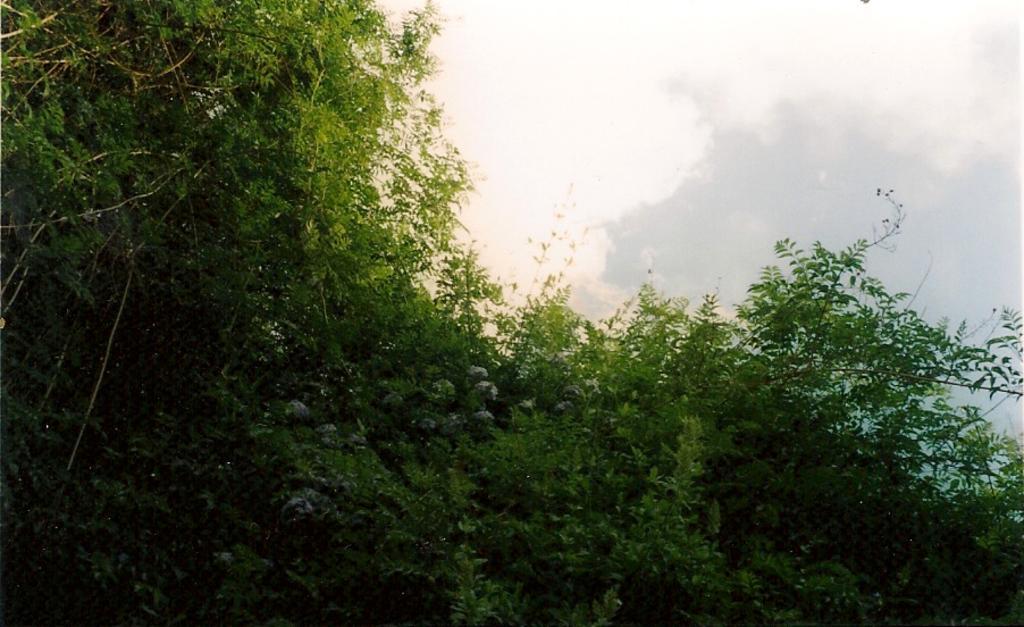In one or two sentences, can you explain what this image depicts? In this image there are trees and the sky. 